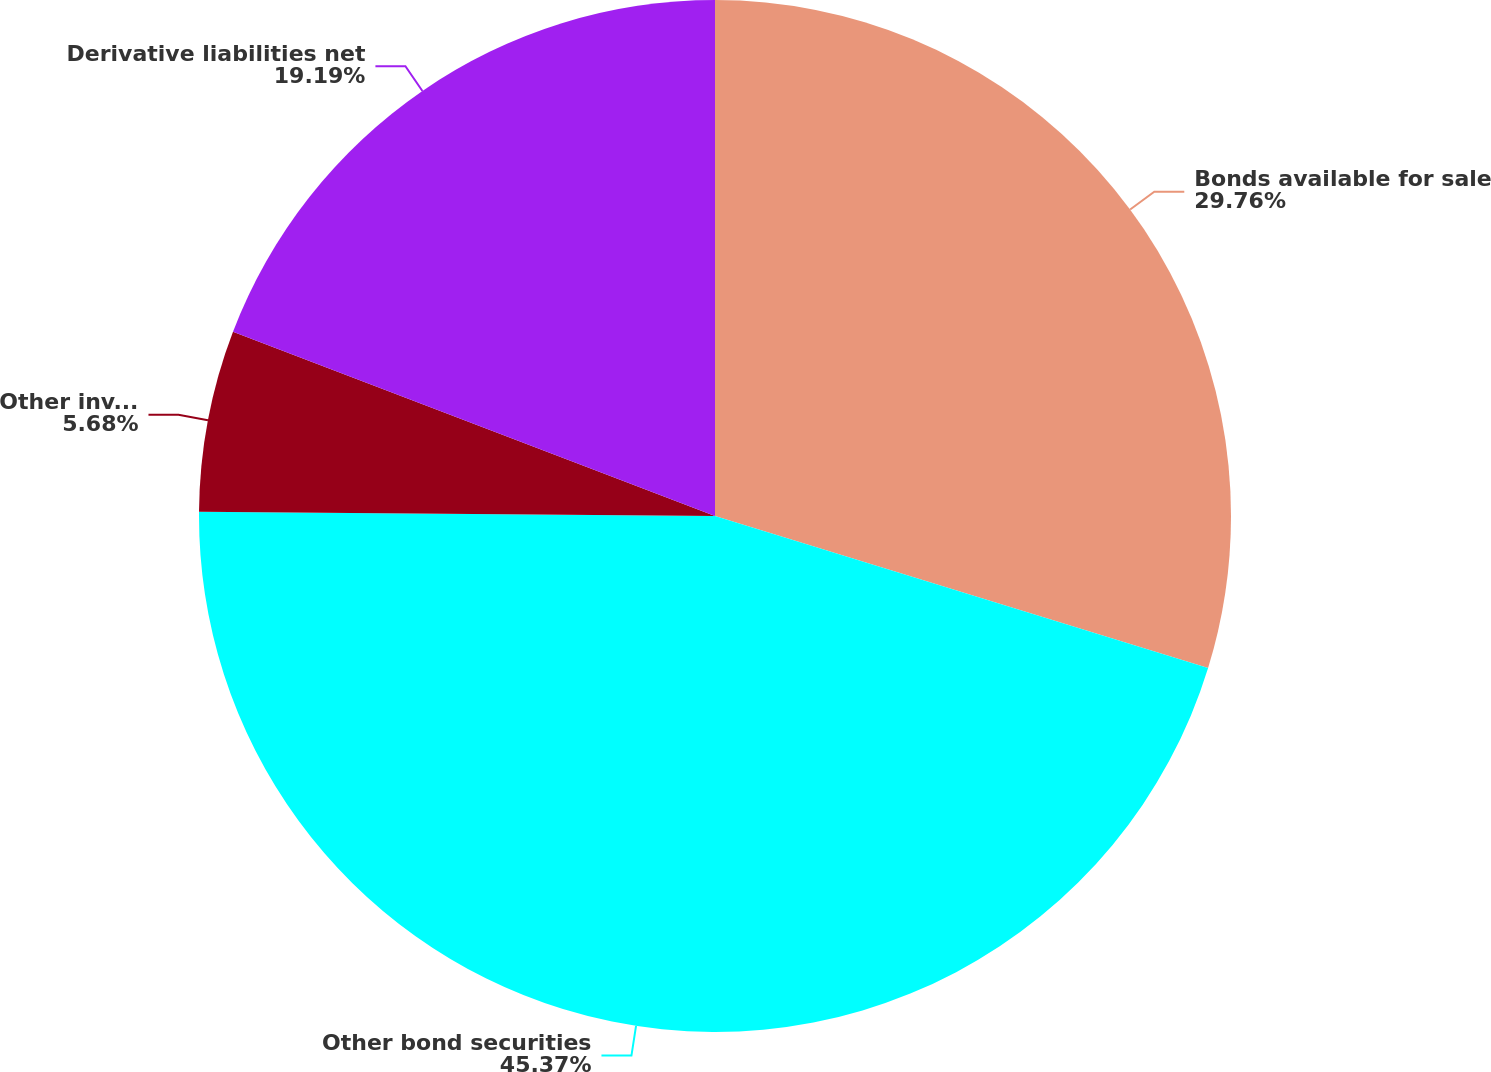<chart> <loc_0><loc_0><loc_500><loc_500><pie_chart><fcel>Bonds available for sale<fcel>Other bond securities<fcel>Other invested assets<fcel>Derivative liabilities net<nl><fcel>29.76%<fcel>45.37%<fcel>5.68%<fcel>19.19%<nl></chart> 